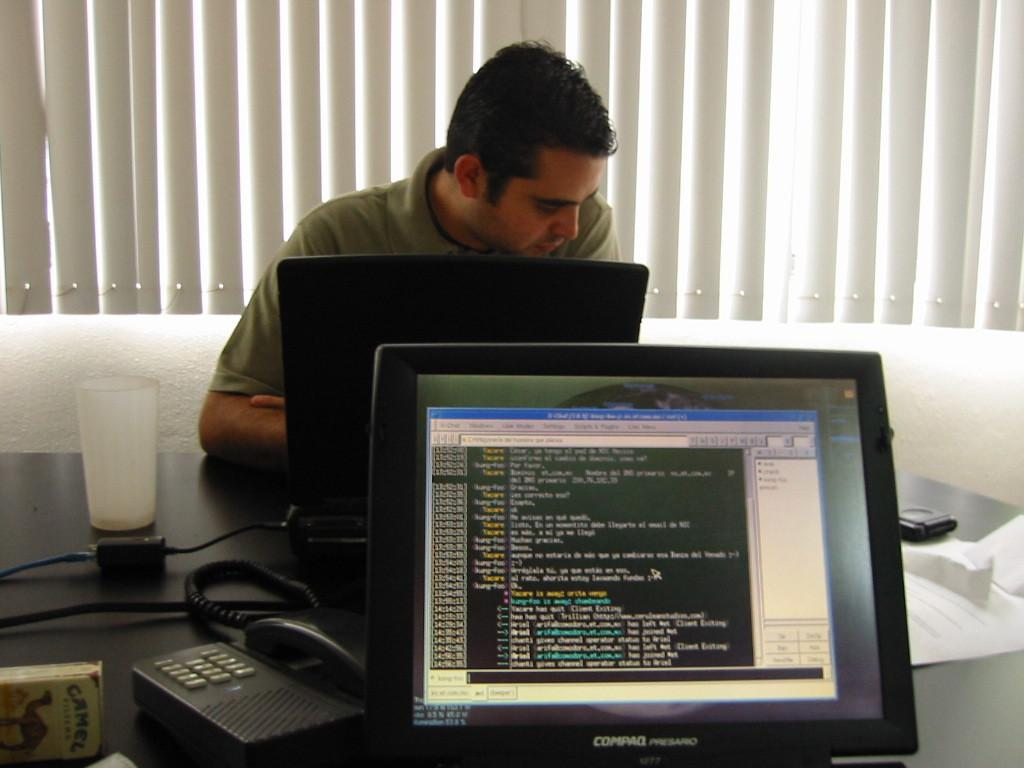<image>
Relay a brief, clear account of the picture shown. The screen of a Compaq monitor displays a large amount of small writing. 